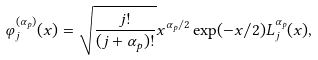Convert formula to latex. <formula><loc_0><loc_0><loc_500><loc_500>\varphi ^ { ( \alpha _ { p } ) } _ { j } ( x ) = \sqrt { \frac { j ! } { ( j + \alpha _ { p } ) ! } } x ^ { \alpha _ { p } / 2 } \exp ( - x / 2 ) L _ { j } ^ { \alpha _ { p } } ( x ) ,</formula> 